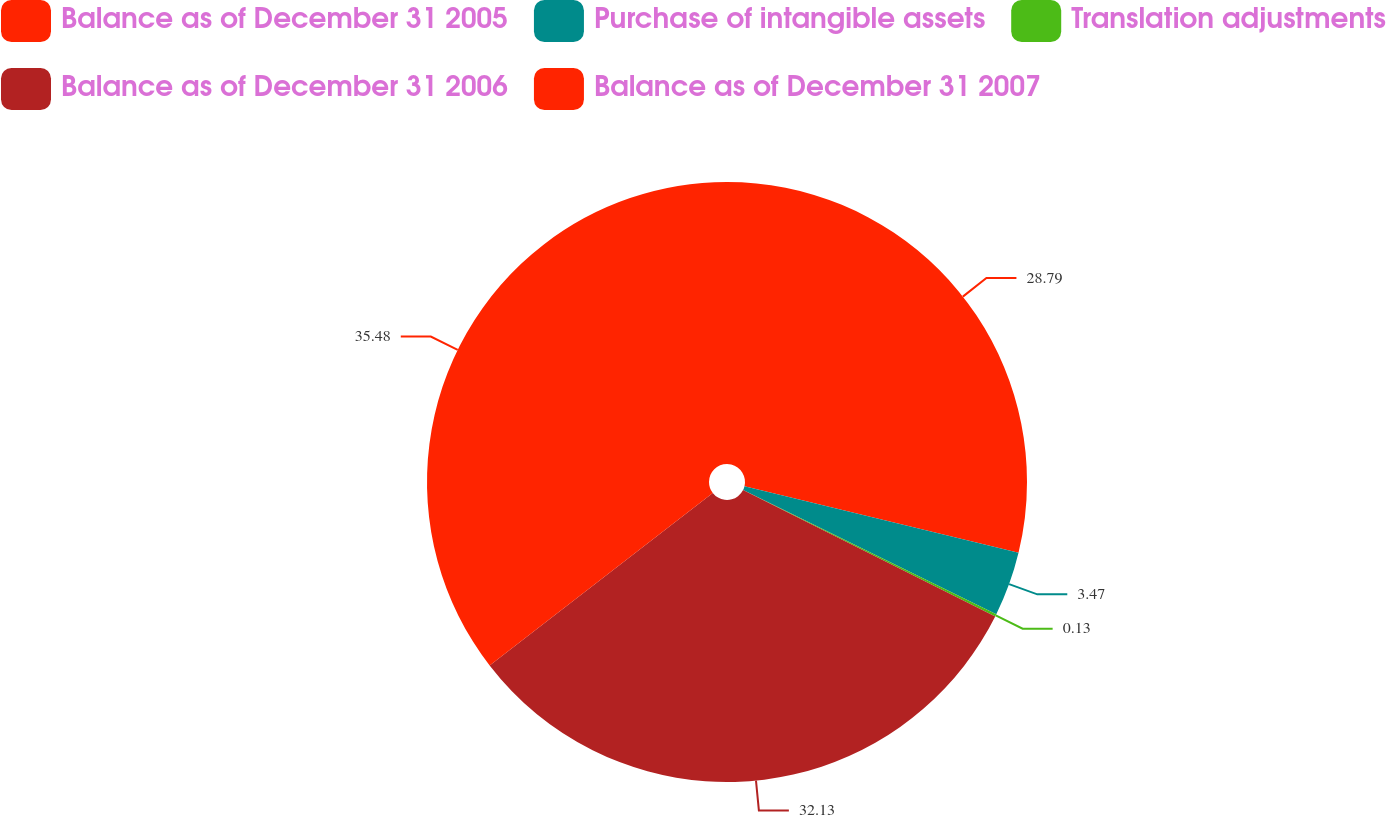Convert chart. <chart><loc_0><loc_0><loc_500><loc_500><pie_chart><fcel>Balance as of December 31 2005<fcel>Purchase of intangible assets<fcel>Translation adjustments<fcel>Balance as of December 31 2006<fcel>Balance as of December 31 2007<nl><fcel>28.79%<fcel>3.47%<fcel>0.13%<fcel>32.13%<fcel>35.47%<nl></chart> 